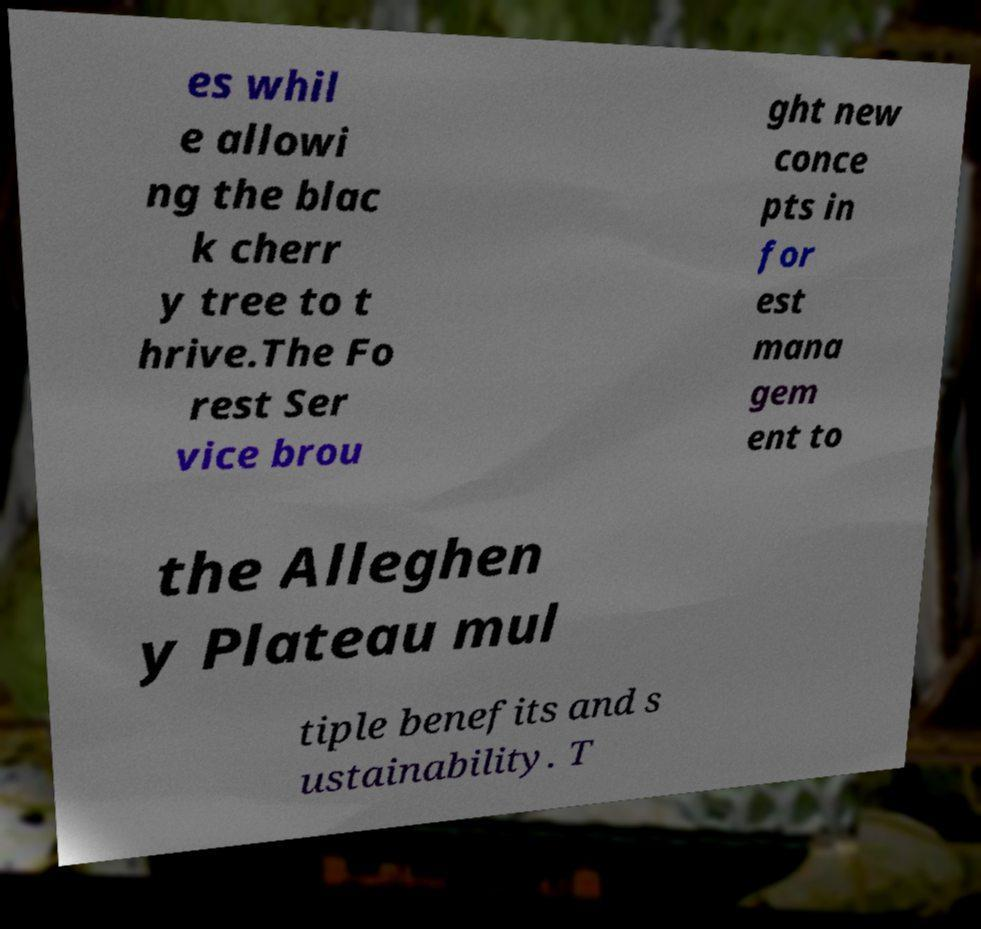Could you assist in decoding the text presented in this image and type it out clearly? es whil e allowi ng the blac k cherr y tree to t hrive.The Fo rest Ser vice brou ght new conce pts in for est mana gem ent to the Alleghen y Plateau mul tiple benefits and s ustainability. T 